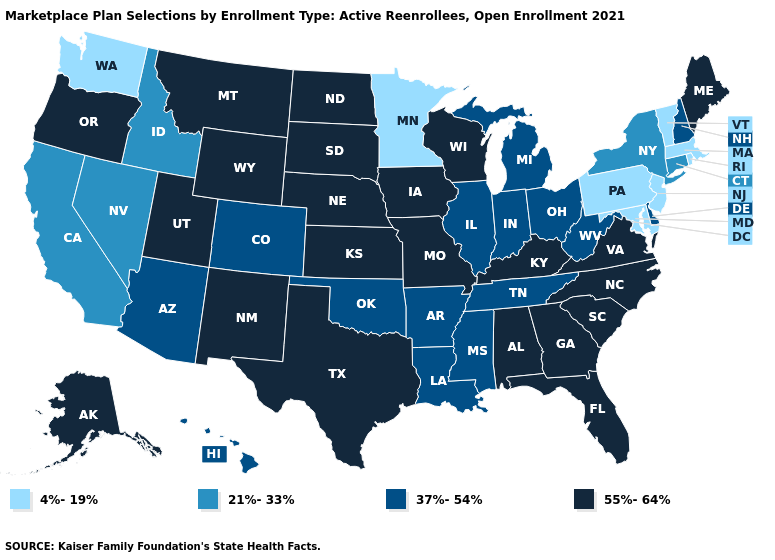Does Colorado have a lower value than Vermont?
Be succinct. No. What is the value of Maine?
Concise answer only. 55%-64%. Does Vermont have a higher value than Montana?
Quick response, please. No. Among the states that border Georgia , does North Carolina have the lowest value?
Be succinct. No. What is the value of Maryland?
Answer briefly. 4%-19%. What is the highest value in the USA?
Give a very brief answer. 55%-64%. What is the value of Idaho?
Short answer required. 21%-33%. What is the highest value in states that border Nevada?
Be succinct. 55%-64%. How many symbols are there in the legend?
Concise answer only. 4. Name the states that have a value in the range 21%-33%?
Keep it brief. California, Connecticut, Idaho, Nevada, New York. Does New York have a higher value than Tennessee?
Write a very short answer. No. Which states have the lowest value in the MidWest?
Concise answer only. Minnesota. What is the lowest value in states that border New Jersey?
Short answer required. 4%-19%. Which states hav the highest value in the West?
Keep it brief. Alaska, Montana, New Mexico, Oregon, Utah, Wyoming. Which states have the highest value in the USA?
Give a very brief answer. Alabama, Alaska, Florida, Georgia, Iowa, Kansas, Kentucky, Maine, Missouri, Montana, Nebraska, New Mexico, North Carolina, North Dakota, Oregon, South Carolina, South Dakota, Texas, Utah, Virginia, Wisconsin, Wyoming. 